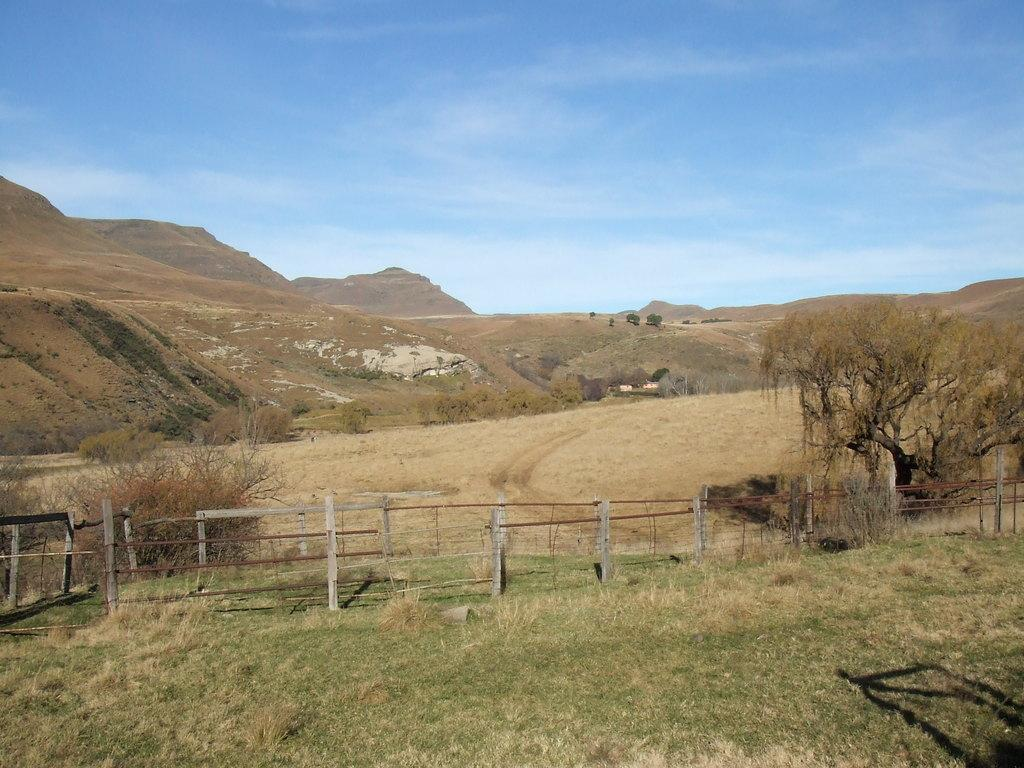What type of vegetation is in the foreground of the image? There is grass in the foreground of the image. What type of barrier is present in the foreground of the image? There is a wooden boundary in the foreground of the image. What type of terrain is in the middle of the image? There is sand in the middle of the image. What geographical features are in the middle of the image? There are hills and trees in the middle of the image. What is visible at the top of the image? The sky is visible at the top of the image. What type of lettuce is being attacked by the birds in the image? There are no birds or lettuce present in the image. What type of wine is being served in the image? There is no wine present in the image. 